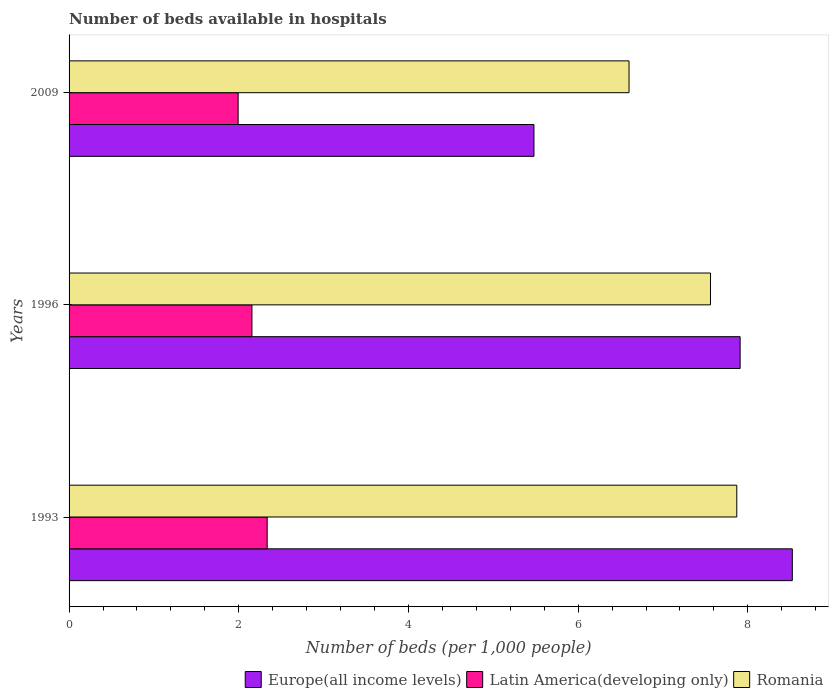How many groups of bars are there?
Offer a very short reply. 3. Are the number of bars on each tick of the Y-axis equal?
Offer a very short reply. Yes. How many bars are there on the 1st tick from the top?
Give a very brief answer. 3. How many bars are there on the 1st tick from the bottom?
Ensure brevity in your answer.  3. What is the number of beds in the hospiatls of in Europe(all income levels) in 1993?
Your answer should be very brief. 8.52. Across all years, what is the maximum number of beds in the hospiatls of in Latin America(developing only)?
Give a very brief answer. 2.34. Across all years, what is the minimum number of beds in the hospiatls of in Europe(all income levels)?
Provide a short and direct response. 5.48. What is the total number of beds in the hospiatls of in Latin America(developing only) in the graph?
Your response must be concise. 6.48. What is the difference between the number of beds in the hospiatls of in Romania in 1993 and that in 1996?
Give a very brief answer. 0.31. What is the difference between the number of beds in the hospiatls of in Latin America(developing only) in 2009 and the number of beds in the hospiatls of in Romania in 1996?
Offer a terse response. -5.57. What is the average number of beds in the hospiatls of in Europe(all income levels) per year?
Provide a short and direct response. 7.3. In the year 1993, what is the difference between the number of beds in the hospiatls of in Latin America(developing only) and number of beds in the hospiatls of in Romania?
Provide a succinct answer. -5.53. In how many years, is the number of beds in the hospiatls of in Romania greater than 6.8 ?
Your answer should be compact. 2. What is the ratio of the number of beds in the hospiatls of in Europe(all income levels) in 1993 to that in 2009?
Give a very brief answer. 1.56. Is the number of beds in the hospiatls of in Latin America(developing only) in 1993 less than that in 2009?
Give a very brief answer. No. What is the difference between the highest and the second highest number of beds in the hospiatls of in Europe(all income levels)?
Ensure brevity in your answer.  0.62. What is the difference between the highest and the lowest number of beds in the hospiatls of in Latin America(developing only)?
Your answer should be compact. 0.34. What does the 2nd bar from the top in 2009 represents?
Your answer should be compact. Latin America(developing only). What does the 1st bar from the bottom in 1996 represents?
Your answer should be compact. Europe(all income levels). How many bars are there?
Give a very brief answer. 9. What is the difference between two consecutive major ticks on the X-axis?
Provide a succinct answer. 2. Are the values on the major ticks of X-axis written in scientific E-notation?
Your answer should be very brief. No. Does the graph contain grids?
Your response must be concise. No. Where does the legend appear in the graph?
Offer a terse response. Bottom right. How many legend labels are there?
Keep it short and to the point. 3. What is the title of the graph?
Provide a succinct answer. Number of beds available in hospitals. Does "Benin" appear as one of the legend labels in the graph?
Your answer should be very brief. No. What is the label or title of the X-axis?
Your response must be concise. Number of beds (per 1,0 people). What is the label or title of the Y-axis?
Offer a terse response. Years. What is the Number of beds (per 1,000 people) of Europe(all income levels) in 1993?
Keep it short and to the point. 8.52. What is the Number of beds (per 1,000 people) in Latin America(developing only) in 1993?
Offer a very short reply. 2.34. What is the Number of beds (per 1,000 people) of Romania in 1993?
Your response must be concise. 7.87. What is the Number of beds (per 1,000 people) in Europe(all income levels) in 1996?
Ensure brevity in your answer.  7.91. What is the Number of beds (per 1,000 people) of Latin America(developing only) in 1996?
Offer a very short reply. 2.16. What is the Number of beds (per 1,000 people) in Romania in 1996?
Offer a terse response. 7.56. What is the Number of beds (per 1,000 people) in Europe(all income levels) in 2009?
Keep it short and to the point. 5.48. What is the Number of beds (per 1,000 people) of Latin America(developing only) in 2009?
Your answer should be compact. 1.99. What is the Number of beds (per 1,000 people) in Romania in 2009?
Your answer should be compact. 6.6. Across all years, what is the maximum Number of beds (per 1,000 people) in Europe(all income levels)?
Give a very brief answer. 8.52. Across all years, what is the maximum Number of beds (per 1,000 people) of Latin America(developing only)?
Your answer should be compact. 2.34. Across all years, what is the maximum Number of beds (per 1,000 people) in Romania?
Provide a short and direct response. 7.87. Across all years, what is the minimum Number of beds (per 1,000 people) of Europe(all income levels)?
Your response must be concise. 5.48. Across all years, what is the minimum Number of beds (per 1,000 people) of Latin America(developing only)?
Offer a terse response. 1.99. Across all years, what is the minimum Number of beds (per 1,000 people) in Romania?
Ensure brevity in your answer.  6.6. What is the total Number of beds (per 1,000 people) of Europe(all income levels) in the graph?
Offer a very short reply. 21.91. What is the total Number of beds (per 1,000 people) in Latin America(developing only) in the graph?
Provide a short and direct response. 6.48. What is the total Number of beds (per 1,000 people) of Romania in the graph?
Provide a short and direct response. 22.03. What is the difference between the Number of beds (per 1,000 people) in Europe(all income levels) in 1993 and that in 1996?
Offer a very short reply. 0.62. What is the difference between the Number of beds (per 1,000 people) in Latin America(developing only) in 1993 and that in 1996?
Make the answer very short. 0.18. What is the difference between the Number of beds (per 1,000 people) of Romania in 1993 and that in 1996?
Provide a short and direct response. 0.31. What is the difference between the Number of beds (per 1,000 people) in Europe(all income levels) in 1993 and that in 2009?
Offer a very short reply. 3.05. What is the difference between the Number of beds (per 1,000 people) of Latin America(developing only) in 1993 and that in 2009?
Provide a succinct answer. 0.34. What is the difference between the Number of beds (per 1,000 people) of Romania in 1993 and that in 2009?
Give a very brief answer. 1.27. What is the difference between the Number of beds (per 1,000 people) of Europe(all income levels) in 1996 and that in 2009?
Provide a short and direct response. 2.43. What is the difference between the Number of beds (per 1,000 people) of Latin America(developing only) in 1996 and that in 2009?
Your answer should be compact. 0.16. What is the difference between the Number of beds (per 1,000 people) of Europe(all income levels) in 1993 and the Number of beds (per 1,000 people) of Latin America(developing only) in 1996?
Make the answer very short. 6.37. What is the difference between the Number of beds (per 1,000 people) in Europe(all income levels) in 1993 and the Number of beds (per 1,000 people) in Romania in 1996?
Make the answer very short. 0.96. What is the difference between the Number of beds (per 1,000 people) of Latin America(developing only) in 1993 and the Number of beds (per 1,000 people) of Romania in 1996?
Your answer should be compact. -5.22. What is the difference between the Number of beds (per 1,000 people) in Europe(all income levels) in 1993 and the Number of beds (per 1,000 people) in Latin America(developing only) in 2009?
Your answer should be compact. 6.53. What is the difference between the Number of beds (per 1,000 people) in Europe(all income levels) in 1993 and the Number of beds (per 1,000 people) in Romania in 2009?
Provide a short and direct response. 1.92. What is the difference between the Number of beds (per 1,000 people) in Latin America(developing only) in 1993 and the Number of beds (per 1,000 people) in Romania in 2009?
Your response must be concise. -4.26. What is the difference between the Number of beds (per 1,000 people) in Europe(all income levels) in 1996 and the Number of beds (per 1,000 people) in Latin America(developing only) in 2009?
Your answer should be very brief. 5.92. What is the difference between the Number of beds (per 1,000 people) of Europe(all income levels) in 1996 and the Number of beds (per 1,000 people) of Romania in 2009?
Provide a short and direct response. 1.31. What is the difference between the Number of beds (per 1,000 people) in Latin America(developing only) in 1996 and the Number of beds (per 1,000 people) in Romania in 2009?
Make the answer very short. -4.44. What is the average Number of beds (per 1,000 people) in Europe(all income levels) per year?
Provide a succinct answer. 7.3. What is the average Number of beds (per 1,000 people) in Latin America(developing only) per year?
Make the answer very short. 2.16. What is the average Number of beds (per 1,000 people) of Romania per year?
Offer a very short reply. 7.34. In the year 1993, what is the difference between the Number of beds (per 1,000 people) in Europe(all income levels) and Number of beds (per 1,000 people) in Latin America(developing only)?
Your answer should be compact. 6.19. In the year 1993, what is the difference between the Number of beds (per 1,000 people) of Europe(all income levels) and Number of beds (per 1,000 people) of Romania?
Provide a short and direct response. 0.65. In the year 1993, what is the difference between the Number of beds (per 1,000 people) of Latin America(developing only) and Number of beds (per 1,000 people) of Romania?
Provide a succinct answer. -5.53. In the year 1996, what is the difference between the Number of beds (per 1,000 people) of Europe(all income levels) and Number of beds (per 1,000 people) of Latin America(developing only)?
Provide a short and direct response. 5.75. In the year 1996, what is the difference between the Number of beds (per 1,000 people) of Europe(all income levels) and Number of beds (per 1,000 people) of Romania?
Your answer should be compact. 0.35. In the year 1996, what is the difference between the Number of beds (per 1,000 people) of Latin America(developing only) and Number of beds (per 1,000 people) of Romania?
Your answer should be very brief. -5.4. In the year 2009, what is the difference between the Number of beds (per 1,000 people) in Europe(all income levels) and Number of beds (per 1,000 people) in Latin America(developing only)?
Your answer should be very brief. 3.49. In the year 2009, what is the difference between the Number of beds (per 1,000 people) in Europe(all income levels) and Number of beds (per 1,000 people) in Romania?
Keep it short and to the point. -1.12. In the year 2009, what is the difference between the Number of beds (per 1,000 people) in Latin America(developing only) and Number of beds (per 1,000 people) in Romania?
Offer a terse response. -4.61. What is the ratio of the Number of beds (per 1,000 people) of Europe(all income levels) in 1993 to that in 1996?
Provide a succinct answer. 1.08. What is the ratio of the Number of beds (per 1,000 people) in Latin America(developing only) in 1993 to that in 1996?
Provide a short and direct response. 1.08. What is the ratio of the Number of beds (per 1,000 people) of Romania in 1993 to that in 1996?
Make the answer very short. 1.04. What is the ratio of the Number of beds (per 1,000 people) in Europe(all income levels) in 1993 to that in 2009?
Provide a short and direct response. 1.56. What is the ratio of the Number of beds (per 1,000 people) of Latin America(developing only) in 1993 to that in 2009?
Provide a short and direct response. 1.17. What is the ratio of the Number of beds (per 1,000 people) in Romania in 1993 to that in 2009?
Your answer should be very brief. 1.19. What is the ratio of the Number of beds (per 1,000 people) in Europe(all income levels) in 1996 to that in 2009?
Give a very brief answer. 1.44. What is the ratio of the Number of beds (per 1,000 people) in Latin America(developing only) in 1996 to that in 2009?
Keep it short and to the point. 1.08. What is the ratio of the Number of beds (per 1,000 people) of Romania in 1996 to that in 2009?
Ensure brevity in your answer.  1.15. What is the difference between the highest and the second highest Number of beds (per 1,000 people) in Europe(all income levels)?
Give a very brief answer. 0.62. What is the difference between the highest and the second highest Number of beds (per 1,000 people) of Latin America(developing only)?
Provide a short and direct response. 0.18. What is the difference between the highest and the second highest Number of beds (per 1,000 people) of Romania?
Your answer should be compact. 0.31. What is the difference between the highest and the lowest Number of beds (per 1,000 people) of Europe(all income levels)?
Make the answer very short. 3.05. What is the difference between the highest and the lowest Number of beds (per 1,000 people) in Latin America(developing only)?
Ensure brevity in your answer.  0.34. What is the difference between the highest and the lowest Number of beds (per 1,000 people) in Romania?
Offer a very short reply. 1.27. 